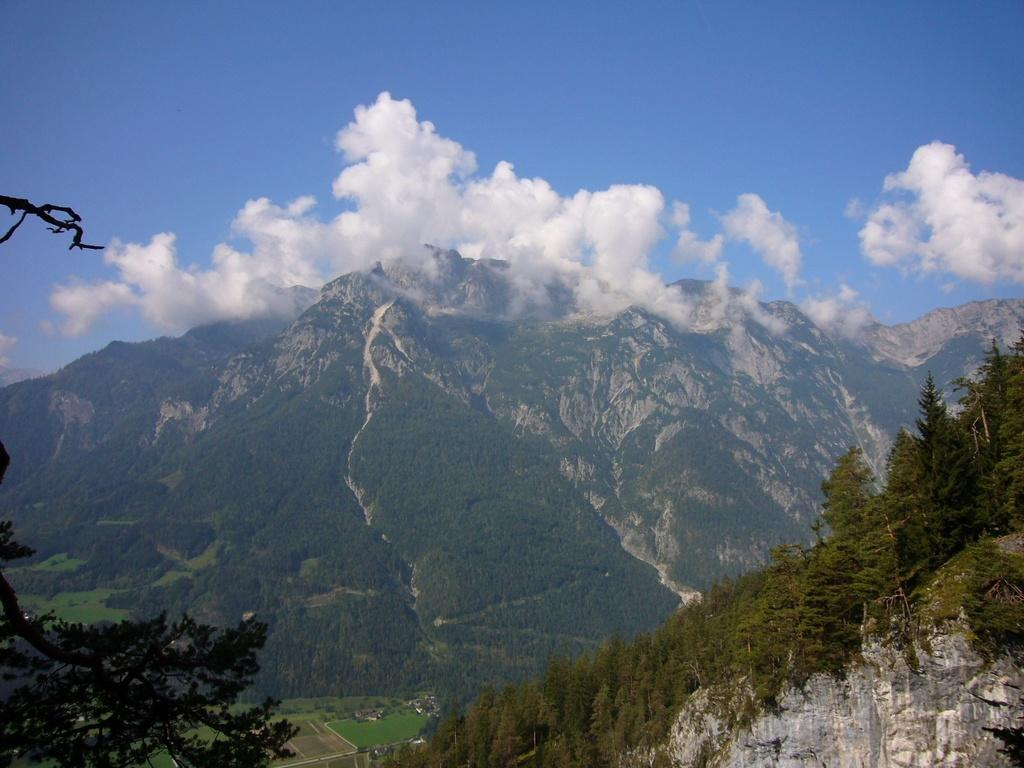What type of natural landform can be seen in the image? There are mountains in the image. What type of vegetation is present in the image? There are trees in the image. What part of the natural environment is visible in the image? The sky is visible in the image. What can be seen in the sky in the image? Clouds are present in the sky in the image. Where are the ants crawling on the flower in the image? There is no flower or ants present in the image. 